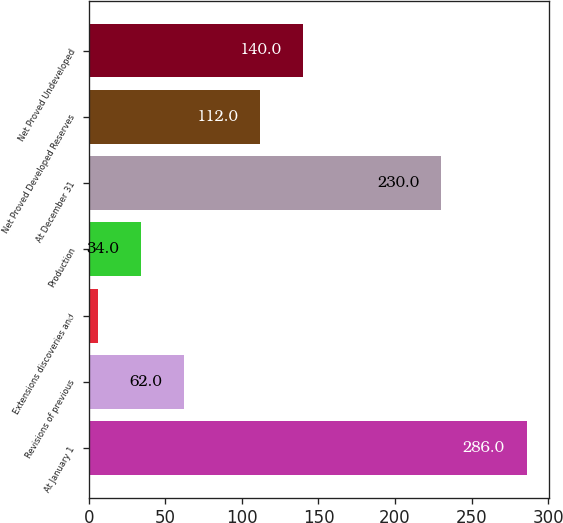Convert chart to OTSL. <chart><loc_0><loc_0><loc_500><loc_500><bar_chart><fcel>At January 1<fcel>Revisions of previous<fcel>Extensions discoveries and<fcel>Production<fcel>At December 31<fcel>Net Proved Developed Reserves<fcel>Net Proved Undeveloped<nl><fcel>286<fcel>62<fcel>6<fcel>34<fcel>230<fcel>112<fcel>140<nl></chart> 